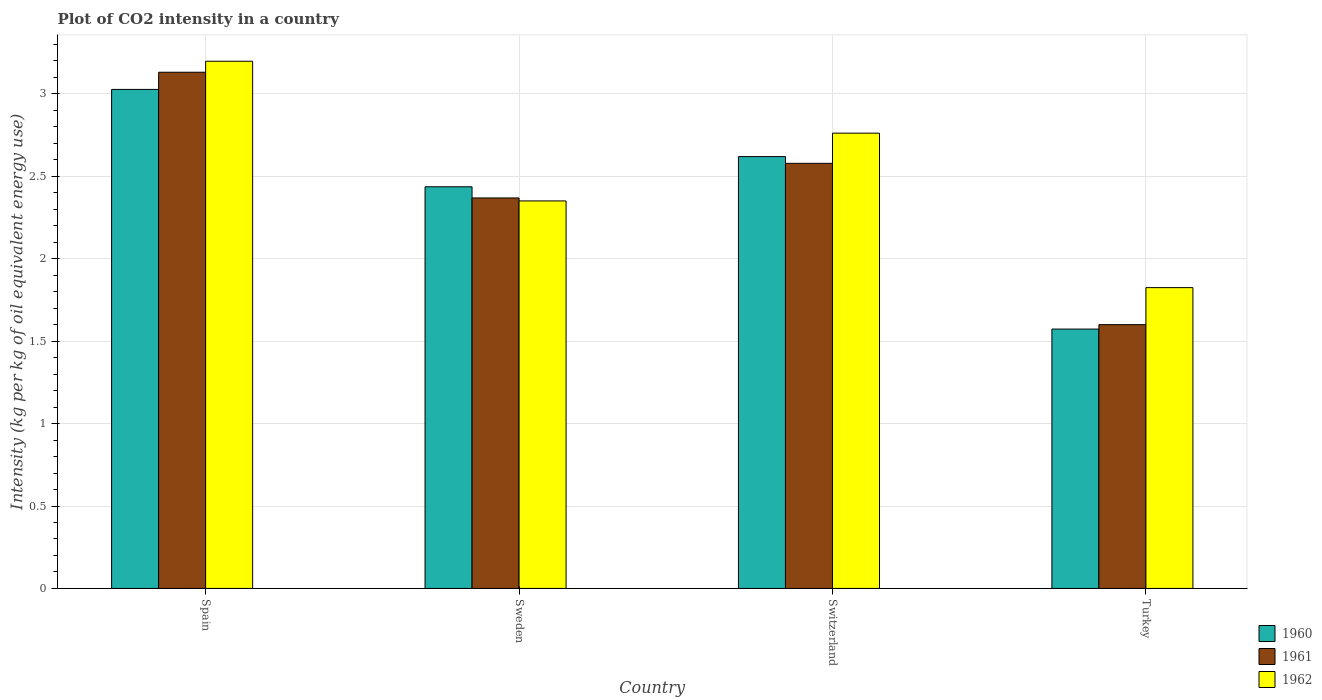How many different coloured bars are there?
Your answer should be compact. 3. How many groups of bars are there?
Your response must be concise. 4. Are the number of bars per tick equal to the number of legend labels?
Keep it short and to the point. Yes. Are the number of bars on each tick of the X-axis equal?
Ensure brevity in your answer.  Yes. What is the label of the 3rd group of bars from the left?
Your answer should be compact. Switzerland. In how many cases, is the number of bars for a given country not equal to the number of legend labels?
Make the answer very short. 0. What is the CO2 intensity in in 1960 in Switzerland?
Your answer should be very brief. 2.62. Across all countries, what is the maximum CO2 intensity in in 1961?
Provide a short and direct response. 3.13. Across all countries, what is the minimum CO2 intensity in in 1962?
Provide a short and direct response. 1.82. What is the total CO2 intensity in in 1961 in the graph?
Keep it short and to the point. 9.68. What is the difference between the CO2 intensity in in 1961 in Sweden and that in Switzerland?
Give a very brief answer. -0.21. What is the difference between the CO2 intensity in in 1961 in Switzerland and the CO2 intensity in in 1960 in Sweden?
Offer a very short reply. 0.14. What is the average CO2 intensity in in 1960 per country?
Your answer should be very brief. 2.41. What is the difference between the CO2 intensity in of/in 1962 and CO2 intensity in of/in 1961 in Turkey?
Keep it short and to the point. 0.22. In how many countries, is the CO2 intensity in in 1962 greater than 1.9 kg?
Offer a terse response. 3. What is the ratio of the CO2 intensity in in 1962 in Spain to that in Turkey?
Ensure brevity in your answer.  1.75. Is the CO2 intensity in in 1960 in Sweden less than that in Turkey?
Your response must be concise. No. What is the difference between the highest and the second highest CO2 intensity in in 1961?
Provide a short and direct response. -0.55. What is the difference between the highest and the lowest CO2 intensity in in 1962?
Your answer should be compact. 1.37. In how many countries, is the CO2 intensity in in 1962 greater than the average CO2 intensity in in 1962 taken over all countries?
Your answer should be very brief. 2. Is the sum of the CO2 intensity in in 1962 in Spain and Switzerland greater than the maximum CO2 intensity in in 1960 across all countries?
Make the answer very short. Yes. What does the 1st bar from the left in Switzerland represents?
Provide a short and direct response. 1960. What does the 2nd bar from the right in Spain represents?
Offer a very short reply. 1961. How many bars are there?
Give a very brief answer. 12. Are all the bars in the graph horizontal?
Give a very brief answer. No. How many countries are there in the graph?
Make the answer very short. 4. Are the values on the major ticks of Y-axis written in scientific E-notation?
Your response must be concise. No. Does the graph contain grids?
Make the answer very short. Yes. Where does the legend appear in the graph?
Ensure brevity in your answer.  Bottom right. How are the legend labels stacked?
Ensure brevity in your answer.  Vertical. What is the title of the graph?
Ensure brevity in your answer.  Plot of CO2 intensity in a country. What is the label or title of the Y-axis?
Your answer should be compact. Intensity (kg per kg of oil equivalent energy use). What is the Intensity (kg per kg of oil equivalent energy use) of 1960 in Spain?
Your answer should be compact. 3.03. What is the Intensity (kg per kg of oil equivalent energy use) of 1961 in Spain?
Provide a succinct answer. 3.13. What is the Intensity (kg per kg of oil equivalent energy use) in 1962 in Spain?
Your answer should be very brief. 3.2. What is the Intensity (kg per kg of oil equivalent energy use) of 1960 in Sweden?
Provide a succinct answer. 2.44. What is the Intensity (kg per kg of oil equivalent energy use) in 1961 in Sweden?
Give a very brief answer. 2.37. What is the Intensity (kg per kg of oil equivalent energy use) of 1962 in Sweden?
Offer a terse response. 2.35. What is the Intensity (kg per kg of oil equivalent energy use) of 1960 in Switzerland?
Keep it short and to the point. 2.62. What is the Intensity (kg per kg of oil equivalent energy use) of 1961 in Switzerland?
Your answer should be compact. 2.58. What is the Intensity (kg per kg of oil equivalent energy use) of 1962 in Switzerland?
Give a very brief answer. 2.76. What is the Intensity (kg per kg of oil equivalent energy use) of 1960 in Turkey?
Keep it short and to the point. 1.57. What is the Intensity (kg per kg of oil equivalent energy use) in 1961 in Turkey?
Keep it short and to the point. 1.6. What is the Intensity (kg per kg of oil equivalent energy use) of 1962 in Turkey?
Keep it short and to the point. 1.82. Across all countries, what is the maximum Intensity (kg per kg of oil equivalent energy use) of 1960?
Provide a short and direct response. 3.03. Across all countries, what is the maximum Intensity (kg per kg of oil equivalent energy use) in 1961?
Your answer should be very brief. 3.13. Across all countries, what is the maximum Intensity (kg per kg of oil equivalent energy use) of 1962?
Ensure brevity in your answer.  3.2. Across all countries, what is the minimum Intensity (kg per kg of oil equivalent energy use) of 1960?
Your response must be concise. 1.57. Across all countries, what is the minimum Intensity (kg per kg of oil equivalent energy use) in 1961?
Make the answer very short. 1.6. Across all countries, what is the minimum Intensity (kg per kg of oil equivalent energy use) in 1962?
Provide a succinct answer. 1.82. What is the total Intensity (kg per kg of oil equivalent energy use) in 1960 in the graph?
Your response must be concise. 9.66. What is the total Intensity (kg per kg of oil equivalent energy use) of 1961 in the graph?
Your answer should be compact. 9.68. What is the total Intensity (kg per kg of oil equivalent energy use) in 1962 in the graph?
Offer a very short reply. 10.14. What is the difference between the Intensity (kg per kg of oil equivalent energy use) in 1960 in Spain and that in Sweden?
Make the answer very short. 0.59. What is the difference between the Intensity (kg per kg of oil equivalent energy use) in 1961 in Spain and that in Sweden?
Offer a very short reply. 0.76. What is the difference between the Intensity (kg per kg of oil equivalent energy use) in 1962 in Spain and that in Sweden?
Provide a succinct answer. 0.85. What is the difference between the Intensity (kg per kg of oil equivalent energy use) in 1960 in Spain and that in Switzerland?
Provide a short and direct response. 0.41. What is the difference between the Intensity (kg per kg of oil equivalent energy use) of 1961 in Spain and that in Switzerland?
Offer a terse response. 0.55. What is the difference between the Intensity (kg per kg of oil equivalent energy use) in 1962 in Spain and that in Switzerland?
Ensure brevity in your answer.  0.44. What is the difference between the Intensity (kg per kg of oil equivalent energy use) of 1960 in Spain and that in Turkey?
Your answer should be compact. 1.45. What is the difference between the Intensity (kg per kg of oil equivalent energy use) of 1961 in Spain and that in Turkey?
Offer a terse response. 1.53. What is the difference between the Intensity (kg per kg of oil equivalent energy use) in 1962 in Spain and that in Turkey?
Your answer should be compact. 1.37. What is the difference between the Intensity (kg per kg of oil equivalent energy use) in 1960 in Sweden and that in Switzerland?
Make the answer very short. -0.18. What is the difference between the Intensity (kg per kg of oil equivalent energy use) of 1961 in Sweden and that in Switzerland?
Offer a very short reply. -0.21. What is the difference between the Intensity (kg per kg of oil equivalent energy use) of 1962 in Sweden and that in Switzerland?
Give a very brief answer. -0.41. What is the difference between the Intensity (kg per kg of oil equivalent energy use) of 1960 in Sweden and that in Turkey?
Provide a short and direct response. 0.86. What is the difference between the Intensity (kg per kg of oil equivalent energy use) of 1961 in Sweden and that in Turkey?
Offer a terse response. 0.77. What is the difference between the Intensity (kg per kg of oil equivalent energy use) in 1962 in Sweden and that in Turkey?
Give a very brief answer. 0.53. What is the difference between the Intensity (kg per kg of oil equivalent energy use) of 1960 in Switzerland and that in Turkey?
Offer a very short reply. 1.05. What is the difference between the Intensity (kg per kg of oil equivalent energy use) in 1961 in Switzerland and that in Turkey?
Keep it short and to the point. 0.98. What is the difference between the Intensity (kg per kg of oil equivalent energy use) of 1962 in Switzerland and that in Turkey?
Make the answer very short. 0.94. What is the difference between the Intensity (kg per kg of oil equivalent energy use) of 1960 in Spain and the Intensity (kg per kg of oil equivalent energy use) of 1961 in Sweden?
Provide a short and direct response. 0.66. What is the difference between the Intensity (kg per kg of oil equivalent energy use) in 1960 in Spain and the Intensity (kg per kg of oil equivalent energy use) in 1962 in Sweden?
Give a very brief answer. 0.68. What is the difference between the Intensity (kg per kg of oil equivalent energy use) in 1961 in Spain and the Intensity (kg per kg of oil equivalent energy use) in 1962 in Sweden?
Ensure brevity in your answer.  0.78. What is the difference between the Intensity (kg per kg of oil equivalent energy use) of 1960 in Spain and the Intensity (kg per kg of oil equivalent energy use) of 1961 in Switzerland?
Make the answer very short. 0.45. What is the difference between the Intensity (kg per kg of oil equivalent energy use) of 1960 in Spain and the Intensity (kg per kg of oil equivalent energy use) of 1962 in Switzerland?
Your answer should be very brief. 0.27. What is the difference between the Intensity (kg per kg of oil equivalent energy use) in 1961 in Spain and the Intensity (kg per kg of oil equivalent energy use) in 1962 in Switzerland?
Keep it short and to the point. 0.37. What is the difference between the Intensity (kg per kg of oil equivalent energy use) in 1960 in Spain and the Intensity (kg per kg of oil equivalent energy use) in 1961 in Turkey?
Your answer should be very brief. 1.43. What is the difference between the Intensity (kg per kg of oil equivalent energy use) in 1960 in Spain and the Intensity (kg per kg of oil equivalent energy use) in 1962 in Turkey?
Ensure brevity in your answer.  1.2. What is the difference between the Intensity (kg per kg of oil equivalent energy use) of 1961 in Spain and the Intensity (kg per kg of oil equivalent energy use) of 1962 in Turkey?
Keep it short and to the point. 1.31. What is the difference between the Intensity (kg per kg of oil equivalent energy use) of 1960 in Sweden and the Intensity (kg per kg of oil equivalent energy use) of 1961 in Switzerland?
Ensure brevity in your answer.  -0.14. What is the difference between the Intensity (kg per kg of oil equivalent energy use) of 1960 in Sweden and the Intensity (kg per kg of oil equivalent energy use) of 1962 in Switzerland?
Offer a very short reply. -0.33. What is the difference between the Intensity (kg per kg of oil equivalent energy use) of 1961 in Sweden and the Intensity (kg per kg of oil equivalent energy use) of 1962 in Switzerland?
Your answer should be very brief. -0.39. What is the difference between the Intensity (kg per kg of oil equivalent energy use) in 1960 in Sweden and the Intensity (kg per kg of oil equivalent energy use) in 1961 in Turkey?
Your answer should be compact. 0.84. What is the difference between the Intensity (kg per kg of oil equivalent energy use) in 1960 in Sweden and the Intensity (kg per kg of oil equivalent energy use) in 1962 in Turkey?
Offer a terse response. 0.61. What is the difference between the Intensity (kg per kg of oil equivalent energy use) of 1961 in Sweden and the Intensity (kg per kg of oil equivalent energy use) of 1962 in Turkey?
Your answer should be very brief. 0.54. What is the difference between the Intensity (kg per kg of oil equivalent energy use) of 1960 in Switzerland and the Intensity (kg per kg of oil equivalent energy use) of 1961 in Turkey?
Provide a succinct answer. 1.02. What is the difference between the Intensity (kg per kg of oil equivalent energy use) of 1960 in Switzerland and the Intensity (kg per kg of oil equivalent energy use) of 1962 in Turkey?
Ensure brevity in your answer.  0.8. What is the difference between the Intensity (kg per kg of oil equivalent energy use) in 1961 in Switzerland and the Intensity (kg per kg of oil equivalent energy use) in 1962 in Turkey?
Offer a terse response. 0.75. What is the average Intensity (kg per kg of oil equivalent energy use) of 1960 per country?
Your answer should be very brief. 2.41. What is the average Intensity (kg per kg of oil equivalent energy use) of 1961 per country?
Your answer should be very brief. 2.42. What is the average Intensity (kg per kg of oil equivalent energy use) of 1962 per country?
Offer a very short reply. 2.53. What is the difference between the Intensity (kg per kg of oil equivalent energy use) in 1960 and Intensity (kg per kg of oil equivalent energy use) in 1961 in Spain?
Offer a very short reply. -0.1. What is the difference between the Intensity (kg per kg of oil equivalent energy use) of 1960 and Intensity (kg per kg of oil equivalent energy use) of 1962 in Spain?
Your answer should be very brief. -0.17. What is the difference between the Intensity (kg per kg of oil equivalent energy use) of 1961 and Intensity (kg per kg of oil equivalent energy use) of 1962 in Spain?
Your answer should be compact. -0.07. What is the difference between the Intensity (kg per kg of oil equivalent energy use) of 1960 and Intensity (kg per kg of oil equivalent energy use) of 1961 in Sweden?
Your response must be concise. 0.07. What is the difference between the Intensity (kg per kg of oil equivalent energy use) in 1960 and Intensity (kg per kg of oil equivalent energy use) in 1962 in Sweden?
Offer a terse response. 0.09. What is the difference between the Intensity (kg per kg of oil equivalent energy use) of 1961 and Intensity (kg per kg of oil equivalent energy use) of 1962 in Sweden?
Provide a short and direct response. 0.02. What is the difference between the Intensity (kg per kg of oil equivalent energy use) of 1960 and Intensity (kg per kg of oil equivalent energy use) of 1961 in Switzerland?
Your response must be concise. 0.04. What is the difference between the Intensity (kg per kg of oil equivalent energy use) in 1960 and Intensity (kg per kg of oil equivalent energy use) in 1962 in Switzerland?
Your response must be concise. -0.14. What is the difference between the Intensity (kg per kg of oil equivalent energy use) in 1961 and Intensity (kg per kg of oil equivalent energy use) in 1962 in Switzerland?
Make the answer very short. -0.18. What is the difference between the Intensity (kg per kg of oil equivalent energy use) in 1960 and Intensity (kg per kg of oil equivalent energy use) in 1961 in Turkey?
Your response must be concise. -0.03. What is the difference between the Intensity (kg per kg of oil equivalent energy use) in 1960 and Intensity (kg per kg of oil equivalent energy use) in 1962 in Turkey?
Your answer should be very brief. -0.25. What is the difference between the Intensity (kg per kg of oil equivalent energy use) of 1961 and Intensity (kg per kg of oil equivalent energy use) of 1962 in Turkey?
Provide a short and direct response. -0.22. What is the ratio of the Intensity (kg per kg of oil equivalent energy use) in 1960 in Spain to that in Sweden?
Your answer should be compact. 1.24. What is the ratio of the Intensity (kg per kg of oil equivalent energy use) of 1961 in Spain to that in Sweden?
Your answer should be very brief. 1.32. What is the ratio of the Intensity (kg per kg of oil equivalent energy use) of 1962 in Spain to that in Sweden?
Your answer should be very brief. 1.36. What is the ratio of the Intensity (kg per kg of oil equivalent energy use) in 1960 in Spain to that in Switzerland?
Provide a short and direct response. 1.16. What is the ratio of the Intensity (kg per kg of oil equivalent energy use) in 1961 in Spain to that in Switzerland?
Give a very brief answer. 1.21. What is the ratio of the Intensity (kg per kg of oil equivalent energy use) in 1962 in Spain to that in Switzerland?
Your answer should be very brief. 1.16. What is the ratio of the Intensity (kg per kg of oil equivalent energy use) of 1960 in Spain to that in Turkey?
Provide a succinct answer. 1.92. What is the ratio of the Intensity (kg per kg of oil equivalent energy use) of 1961 in Spain to that in Turkey?
Your answer should be compact. 1.96. What is the ratio of the Intensity (kg per kg of oil equivalent energy use) of 1962 in Spain to that in Turkey?
Provide a short and direct response. 1.75. What is the ratio of the Intensity (kg per kg of oil equivalent energy use) in 1960 in Sweden to that in Switzerland?
Your response must be concise. 0.93. What is the ratio of the Intensity (kg per kg of oil equivalent energy use) in 1961 in Sweden to that in Switzerland?
Your answer should be compact. 0.92. What is the ratio of the Intensity (kg per kg of oil equivalent energy use) in 1962 in Sweden to that in Switzerland?
Offer a terse response. 0.85. What is the ratio of the Intensity (kg per kg of oil equivalent energy use) in 1960 in Sweden to that in Turkey?
Ensure brevity in your answer.  1.55. What is the ratio of the Intensity (kg per kg of oil equivalent energy use) in 1961 in Sweden to that in Turkey?
Give a very brief answer. 1.48. What is the ratio of the Intensity (kg per kg of oil equivalent energy use) of 1962 in Sweden to that in Turkey?
Offer a terse response. 1.29. What is the ratio of the Intensity (kg per kg of oil equivalent energy use) in 1960 in Switzerland to that in Turkey?
Offer a very short reply. 1.67. What is the ratio of the Intensity (kg per kg of oil equivalent energy use) in 1961 in Switzerland to that in Turkey?
Offer a terse response. 1.61. What is the ratio of the Intensity (kg per kg of oil equivalent energy use) in 1962 in Switzerland to that in Turkey?
Provide a succinct answer. 1.51. What is the difference between the highest and the second highest Intensity (kg per kg of oil equivalent energy use) in 1960?
Provide a short and direct response. 0.41. What is the difference between the highest and the second highest Intensity (kg per kg of oil equivalent energy use) of 1961?
Offer a terse response. 0.55. What is the difference between the highest and the second highest Intensity (kg per kg of oil equivalent energy use) of 1962?
Your response must be concise. 0.44. What is the difference between the highest and the lowest Intensity (kg per kg of oil equivalent energy use) in 1960?
Your response must be concise. 1.45. What is the difference between the highest and the lowest Intensity (kg per kg of oil equivalent energy use) in 1961?
Ensure brevity in your answer.  1.53. What is the difference between the highest and the lowest Intensity (kg per kg of oil equivalent energy use) in 1962?
Your answer should be very brief. 1.37. 